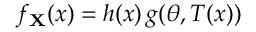Convert formula to latex. <formula><loc_0><loc_0><loc_500><loc_500>f _ { X } ( x ) = h ( x ) \, g ( \theta , T ( x ) )</formula> 